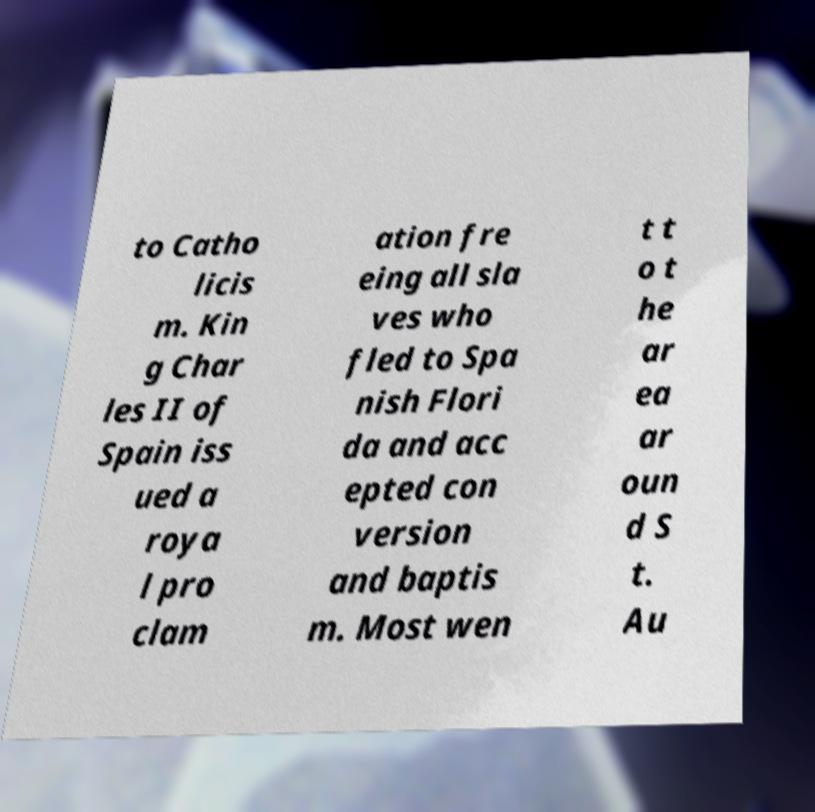Could you assist in decoding the text presented in this image and type it out clearly? to Catho licis m. Kin g Char les II of Spain iss ued a roya l pro clam ation fre eing all sla ves who fled to Spa nish Flori da and acc epted con version and baptis m. Most wen t t o t he ar ea ar oun d S t. Au 